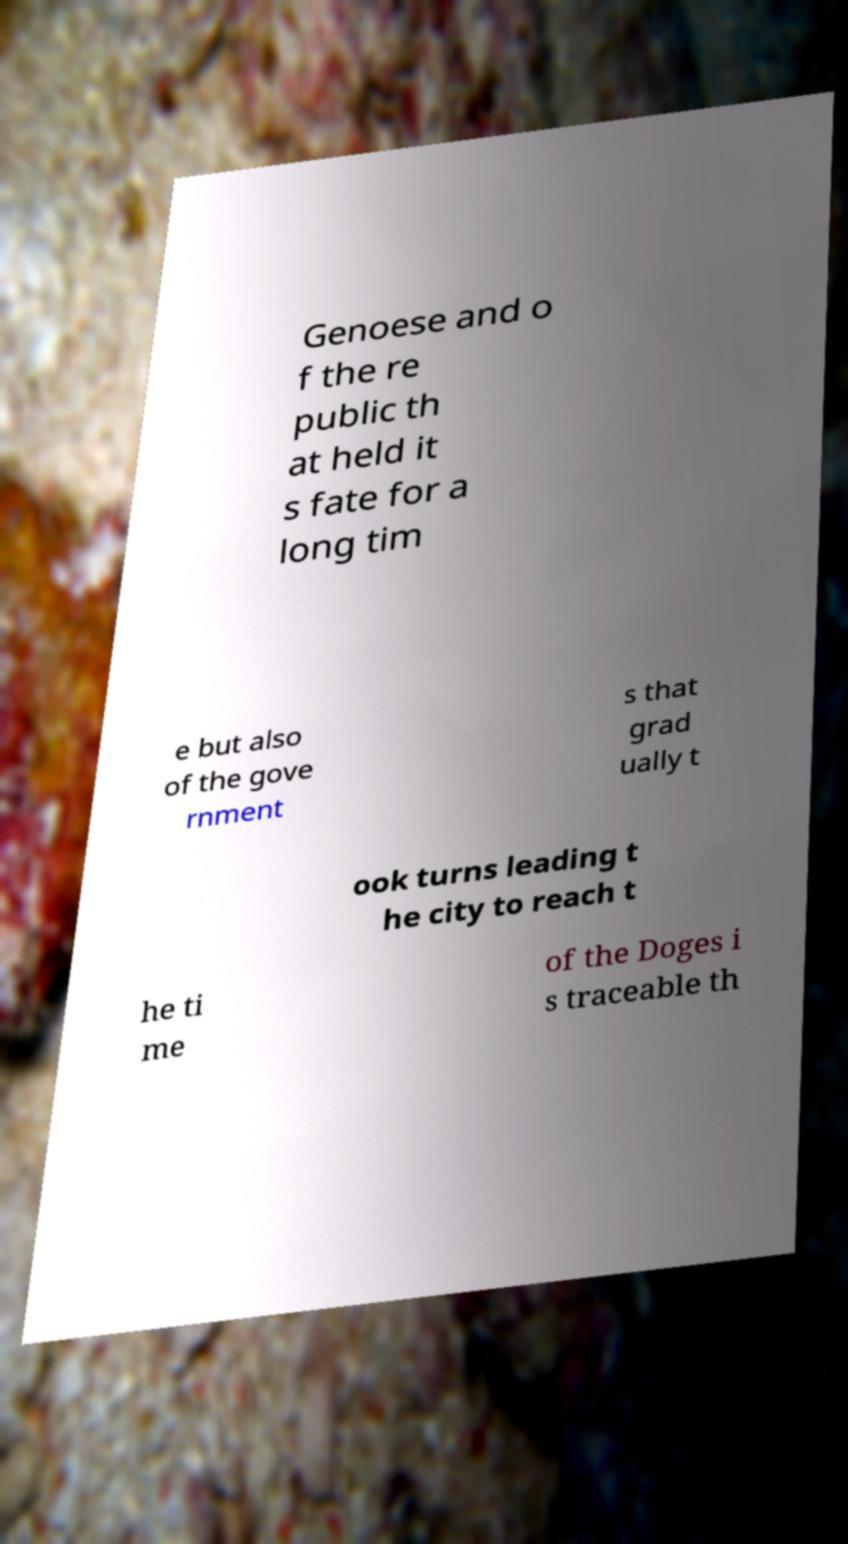Can you read and provide the text displayed in the image?This photo seems to have some interesting text. Can you extract and type it out for me? Genoese and o f the re public th at held it s fate for a long tim e but also of the gove rnment s that grad ually t ook turns leading t he city to reach t he ti me of the Doges i s traceable th 